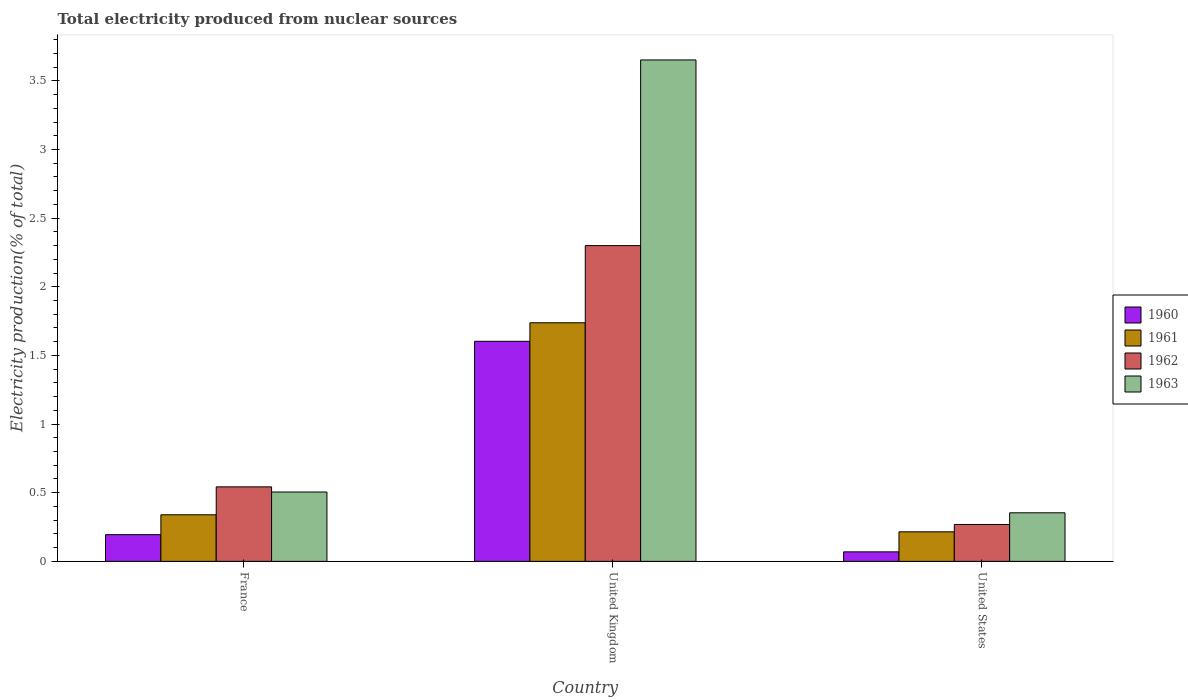How many groups of bars are there?
Provide a short and direct response. 3. How many bars are there on the 3rd tick from the left?
Make the answer very short. 4. How many bars are there on the 1st tick from the right?
Provide a short and direct response. 4. What is the total electricity produced in 1962 in France?
Offer a terse response. 0.54. Across all countries, what is the maximum total electricity produced in 1963?
Provide a short and direct response. 3.65. Across all countries, what is the minimum total electricity produced in 1960?
Keep it short and to the point. 0.07. What is the total total electricity produced in 1960 in the graph?
Give a very brief answer. 1.87. What is the difference between the total electricity produced in 1960 in France and that in United States?
Give a very brief answer. 0.13. What is the difference between the total electricity produced in 1962 in France and the total electricity produced in 1960 in United States?
Your answer should be very brief. 0.47. What is the average total electricity produced in 1960 per country?
Your answer should be compact. 0.62. What is the difference between the total electricity produced of/in 1961 and total electricity produced of/in 1963 in France?
Keep it short and to the point. -0.17. What is the ratio of the total electricity produced in 1961 in United Kingdom to that in United States?
Provide a succinct answer. 8.08. Is the total electricity produced in 1961 in France less than that in United States?
Ensure brevity in your answer.  No. Is the difference between the total electricity produced in 1961 in France and United Kingdom greater than the difference between the total electricity produced in 1963 in France and United Kingdom?
Your answer should be compact. Yes. What is the difference between the highest and the second highest total electricity produced in 1960?
Make the answer very short. -1.41. What is the difference between the highest and the lowest total electricity produced in 1960?
Give a very brief answer. 1.53. What does the 1st bar from the left in United Kingdom represents?
Offer a terse response. 1960. What does the 4th bar from the right in United States represents?
Your answer should be compact. 1960. Is it the case that in every country, the sum of the total electricity produced in 1963 and total electricity produced in 1962 is greater than the total electricity produced in 1960?
Give a very brief answer. Yes. Are all the bars in the graph horizontal?
Provide a short and direct response. No. Are the values on the major ticks of Y-axis written in scientific E-notation?
Keep it short and to the point. No. Does the graph contain any zero values?
Provide a succinct answer. No. What is the title of the graph?
Give a very brief answer. Total electricity produced from nuclear sources. Does "1988" appear as one of the legend labels in the graph?
Your response must be concise. No. What is the Electricity production(% of total) in 1960 in France?
Your answer should be very brief. 0.19. What is the Electricity production(% of total) in 1961 in France?
Keep it short and to the point. 0.34. What is the Electricity production(% of total) of 1962 in France?
Provide a short and direct response. 0.54. What is the Electricity production(% of total) in 1963 in France?
Provide a short and direct response. 0.51. What is the Electricity production(% of total) in 1960 in United Kingdom?
Give a very brief answer. 1.6. What is the Electricity production(% of total) of 1961 in United Kingdom?
Offer a very short reply. 1.74. What is the Electricity production(% of total) of 1962 in United Kingdom?
Ensure brevity in your answer.  2.3. What is the Electricity production(% of total) in 1963 in United Kingdom?
Provide a short and direct response. 3.65. What is the Electricity production(% of total) in 1960 in United States?
Your answer should be compact. 0.07. What is the Electricity production(% of total) in 1961 in United States?
Keep it short and to the point. 0.22. What is the Electricity production(% of total) of 1962 in United States?
Your answer should be compact. 0.27. What is the Electricity production(% of total) in 1963 in United States?
Your answer should be very brief. 0.35. Across all countries, what is the maximum Electricity production(% of total) of 1960?
Offer a terse response. 1.6. Across all countries, what is the maximum Electricity production(% of total) of 1961?
Provide a short and direct response. 1.74. Across all countries, what is the maximum Electricity production(% of total) of 1962?
Your answer should be compact. 2.3. Across all countries, what is the maximum Electricity production(% of total) of 1963?
Offer a terse response. 3.65. Across all countries, what is the minimum Electricity production(% of total) of 1960?
Offer a terse response. 0.07. Across all countries, what is the minimum Electricity production(% of total) in 1961?
Provide a short and direct response. 0.22. Across all countries, what is the minimum Electricity production(% of total) in 1962?
Make the answer very short. 0.27. Across all countries, what is the minimum Electricity production(% of total) in 1963?
Give a very brief answer. 0.35. What is the total Electricity production(% of total) of 1960 in the graph?
Your answer should be compact. 1.87. What is the total Electricity production(% of total) in 1961 in the graph?
Offer a very short reply. 2.29. What is the total Electricity production(% of total) in 1962 in the graph?
Keep it short and to the point. 3.11. What is the total Electricity production(% of total) in 1963 in the graph?
Ensure brevity in your answer.  4.51. What is the difference between the Electricity production(% of total) in 1960 in France and that in United Kingdom?
Your response must be concise. -1.41. What is the difference between the Electricity production(% of total) in 1961 in France and that in United Kingdom?
Your answer should be very brief. -1.4. What is the difference between the Electricity production(% of total) in 1962 in France and that in United Kingdom?
Keep it short and to the point. -1.76. What is the difference between the Electricity production(% of total) of 1963 in France and that in United Kingdom?
Provide a short and direct response. -3.15. What is the difference between the Electricity production(% of total) of 1960 in France and that in United States?
Offer a terse response. 0.13. What is the difference between the Electricity production(% of total) of 1961 in France and that in United States?
Your answer should be very brief. 0.12. What is the difference between the Electricity production(% of total) of 1962 in France and that in United States?
Ensure brevity in your answer.  0.27. What is the difference between the Electricity production(% of total) in 1963 in France and that in United States?
Make the answer very short. 0.15. What is the difference between the Electricity production(% of total) in 1960 in United Kingdom and that in United States?
Keep it short and to the point. 1.53. What is the difference between the Electricity production(% of total) in 1961 in United Kingdom and that in United States?
Provide a succinct answer. 1.52. What is the difference between the Electricity production(% of total) of 1962 in United Kingdom and that in United States?
Give a very brief answer. 2.03. What is the difference between the Electricity production(% of total) in 1963 in United Kingdom and that in United States?
Your answer should be compact. 3.3. What is the difference between the Electricity production(% of total) in 1960 in France and the Electricity production(% of total) in 1961 in United Kingdom?
Keep it short and to the point. -1.54. What is the difference between the Electricity production(% of total) of 1960 in France and the Electricity production(% of total) of 1962 in United Kingdom?
Provide a short and direct response. -2.11. What is the difference between the Electricity production(% of total) in 1960 in France and the Electricity production(% of total) in 1963 in United Kingdom?
Give a very brief answer. -3.46. What is the difference between the Electricity production(% of total) in 1961 in France and the Electricity production(% of total) in 1962 in United Kingdom?
Provide a succinct answer. -1.96. What is the difference between the Electricity production(% of total) of 1961 in France and the Electricity production(% of total) of 1963 in United Kingdom?
Your answer should be compact. -3.31. What is the difference between the Electricity production(% of total) in 1962 in France and the Electricity production(% of total) in 1963 in United Kingdom?
Your answer should be compact. -3.11. What is the difference between the Electricity production(% of total) of 1960 in France and the Electricity production(% of total) of 1961 in United States?
Make the answer very short. -0.02. What is the difference between the Electricity production(% of total) in 1960 in France and the Electricity production(% of total) in 1962 in United States?
Your response must be concise. -0.07. What is the difference between the Electricity production(% of total) in 1960 in France and the Electricity production(% of total) in 1963 in United States?
Offer a very short reply. -0.16. What is the difference between the Electricity production(% of total) of 1961 in France and the Electricity production(% of total) of 1962 in United States?
Offer a terse response. 0.07. What is the difference between the Electricity production(% of total) in 1961 in France and the Electricity production(% of total) in 1963 in United States?
Your response must be concise. -0.01. What is the difference between the Electricity production(% of total) in 1962 in France and the Electricity production(% of total) in 1963 in United States?
Your answer should be compact. 0.19. What is the difference between the Electricity production(% of total) of 1960 in United Kingdom and the Electricity production(% of total) of 1961 in United States?
Your answer should be very brief. 1.39. What is the difference between the Electricity production(% of total) of 1960 in United Kingdom and the Electricity production(% of total) of 1962 in United States?
Offer a very short reply. 1.33. What is the difference between the Electricity production(% of total) in 1960 in United Kingdom and the Electricity production(% of total) in 1963 in United States?
Ensure brevity in your answer.  1.25. What is the difference between the Electricity production(% of total) of 1961 in United Kingdom and the Electricity production(% of total) of 1962 in United States?
Make the answer very short. 1.47. What is the difference between the Electricity production(% of total) in 1961 in United Kingdom and the Electricity production(% of total) in 1963 in United States?
Offer a terse response. 1.38. What is the difference between the Electricity production(% of total) in 1962 in United Kingdom and the Electricity production(% of total) in 1963 in United States?
Provide a short and direct response. 1.95. What is the average Electricity production(% of total) in 1960 per country?
Make the answer very short. 0.62. What is the average Electricity production(% of total) of 1961 per country?
Ensure brevity in your answer.  0.76. What is the average Electricity production(% of total) in 1962 per country?
Provide a succinct answer. 1.04. What is the average Electricity production(% of total) in 1963 per country?
Your response must be concise. 1.5. What is the difference between the Electricity production(% of total) of 1960 and Electricity production(% of total) of 1961 in France?
Provide a succinct answer. -0.14. What is the difference between the Electricity production(% of total) in 1960 and Electricity production(% of total) in 1962 in France?
Keep it short and to the point. -0.35. What is the difference between the Electricity production(% of total) of 1960 and Electricity production(% of total) of 1963 in France?
Ensure brevity in your answer.  -0.31. What is the difference between the Electricity production(% of total) in 1961 and Electricity production(% of total) in 1962 in France?
Make the answer very short. -0.2. What is the difference between the Electricity production(% of total) of 1961 and Electricity production(% of total) of 1963 in France?
Ensure brevity in your answer.  -0.17. What is the difference between the Electricity production(% of total) of 1962 and Electricity production(% of total) of 1963 in France?
Ensure brevity in your answer.  0.04. What is the difference between the Electricity production(% of total) of 1960 and Electricity production(% of total) of 1961 in United Kingdom?
Offer a very short reply. -0.13. What is the difference between the Electricity production(% of total) of 1960 and Electricity production(% of total) of 1962 in United Kingdom?
Offer a terse response. -0.7. What is the difference between the Electricity production(% of total) of 1960 and Electricity production(% of total) of 1963 in United Kingdom?
Provide a succinct answer. -2.05. What is the difference between the Electricity production(% of total) in 1961 and Electricity production(% of total) in 1962 in United Kingdom?
Keep it short and to the point. -0.56. What is the difference between the Electricity production(% of total) in 1961 and Electricity production(% of total) in 1963 in United Kingdom?
Your answer should be compact. -1.91. What is the difference between the Electricity production(% of total) in 1962 and Electricity production(% of total) in 1963 in United Kingdom?
Your response must be concise. -1.35. What is the difference between the Electricity production(% of total) in 1960 and Electricity production(% of total) in 1961 in United States?
Offer a terse response. -0.15. What is the difference between the Electricity production(% of total) in 1960 and Electricity production(% of total) in 1962 in United States?
Your answer should be compact. -0.2. What is the difference between the Electricity production(% of total) in 1960 and Electricity production(% of total) in 1963 in United States?
Make the answer very short. -0.28. What is the difference between the Electricity production(% of total) in 1961 and Electricity production(% of total) in 1962 in United States?
Provide a short and direct response. -0.05. What is the difference between the Electricity production(% of total) of 1961 and Electricity production(% of total) of 1963 in United States?
Your response must be concise. -0.14. What is the difference between the Electricity production(% of total) of 1962 and Electricity production(% of total) of 1963 in United States?
Your response must be concise. -0.09. What is the ratio of the Electricity production(% of total) in 1960 in France to that in United Kingdom?
Offer a very short reply. 0.12. What is the ratio of the Electricity production(% of total) in 1961 in France to that in United Kingdom?
Offer a very short reply. 0.2. What is the ratio of the Electricity production(% of total) in 1962 in France to that in United Kingdom?
Your answer should be very brief. 0.24. What is the ratio of the Electricity production(% of total) in 1963 in France to that in United Kingdom?
Your answer should be compact. 0.14. What is the ratio of the Electricity production(% of total) in 1960 in France to that in United States?
Provide a short and direct response. 2.81. What is the ratio of the Electricity production(% of total) of 1961 in France to that in United States?
Your answer should be very brief. 1.58. What is the ratio of the Electricity production(% of total) in 1962 in France to that in United States?
Your answer should be very brief. 2.02. What is the ratio of the Electricity production(% of total) of 1963 in France to that in United States?
Your answer should be very brief. 1.43. What is the ratio of the Electricity production(% of total) in 1960 in United Kingdom to that in United States?
Offer a very short reply. 23.14. What is the ratio of the Electricity production(% of total) of 1961 in United Kingdom to that in United States?
Provide a succinct answer. 8.08. What is the ratio of the Electricity production(% of total) in 1962 in United Kingdom to that in United States?
Provide a succinct answer. 8.56. What is the ratio of the Electricity production(% of total) in 1963 in United Kingdom to that in United States?
Offer a very short reply. 10.32. What is the difference between the highest and the second highest Electricity production(% of total) of 1960?
Give a very brief answer. 1.41. What is the difference between the highest and the second highest Electricity production(% of total) of 1961?
Your answer should be compact. 1.4. What is the difference between the highest and the second highest Electricity production(% of total) in 1962?
Ensure brevity in your answer.  1.76. What is the difference between the highest and the second highest Electricity production(% of total) in 1963?
Your response must be concise. 3.15. What is the difference between the highest and the lowest Electricity production(% of total) of 1960?
Your answer should be very brief. 1.53. What is the difference between the highest and the lowest Electricity production(% of total) of 1961?
Your answer should be very brief. 1.52. What is the difference between the highest and the lowest Electricity production(% of total) in 1962?
Provide a short and direct response. 2.03. What is the difference between the highest and the lowest Electricity production(% of total) of 1963?
Give a very brief answer. 3.3. 